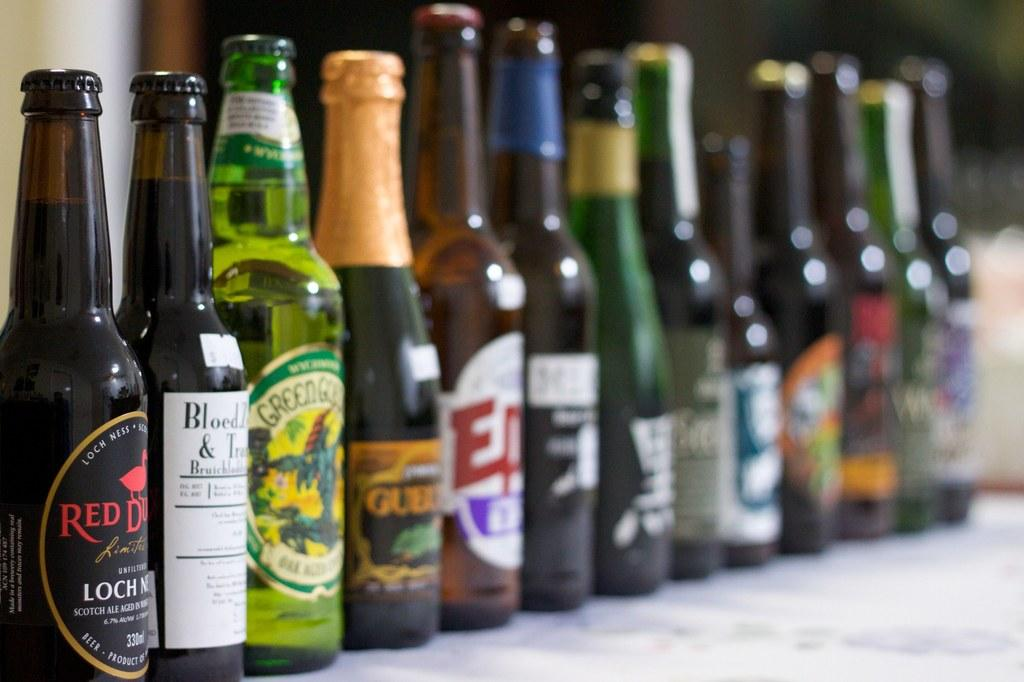Provide a one-sentence caption for the provided image. A bottle of Red Duck Loch Ness beer sitting next to other alcoholic beverages. 